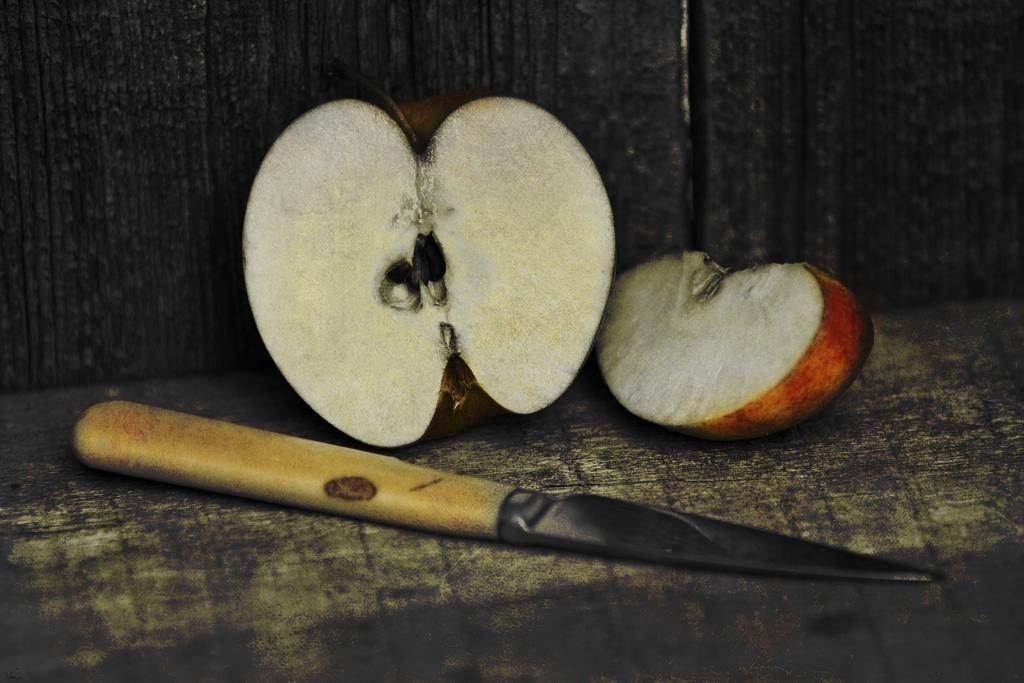What type of fruit is shown in the image? There are two pieces of an apple in the image. What object is used to cut the apple? There is a knife in the image. Where are the apple pieces and knife placed? They are placed on a wooden table. What can be seen in the background of the image? There is a wooden board visible in the background of the image. Reasoning: Let's let's think step by step in order to produce the conversation. We start by identifying the main subject in the image, which is the apple pieces. Then, we expand the conversation to include the knife, which was used to cut the apple, and the wooden table where they are placed. Finally, we mention the wooden board visible in the background. Each question is designed to elicit a specific detail about the image that is known from the provided facts. Absurd Question/Answer: Can you see an airplane flying over the apple pieces in the image? No, there is no airplane present in the image. Are there any farm animals visible in the image? No, there are no farm animals present in the image. 